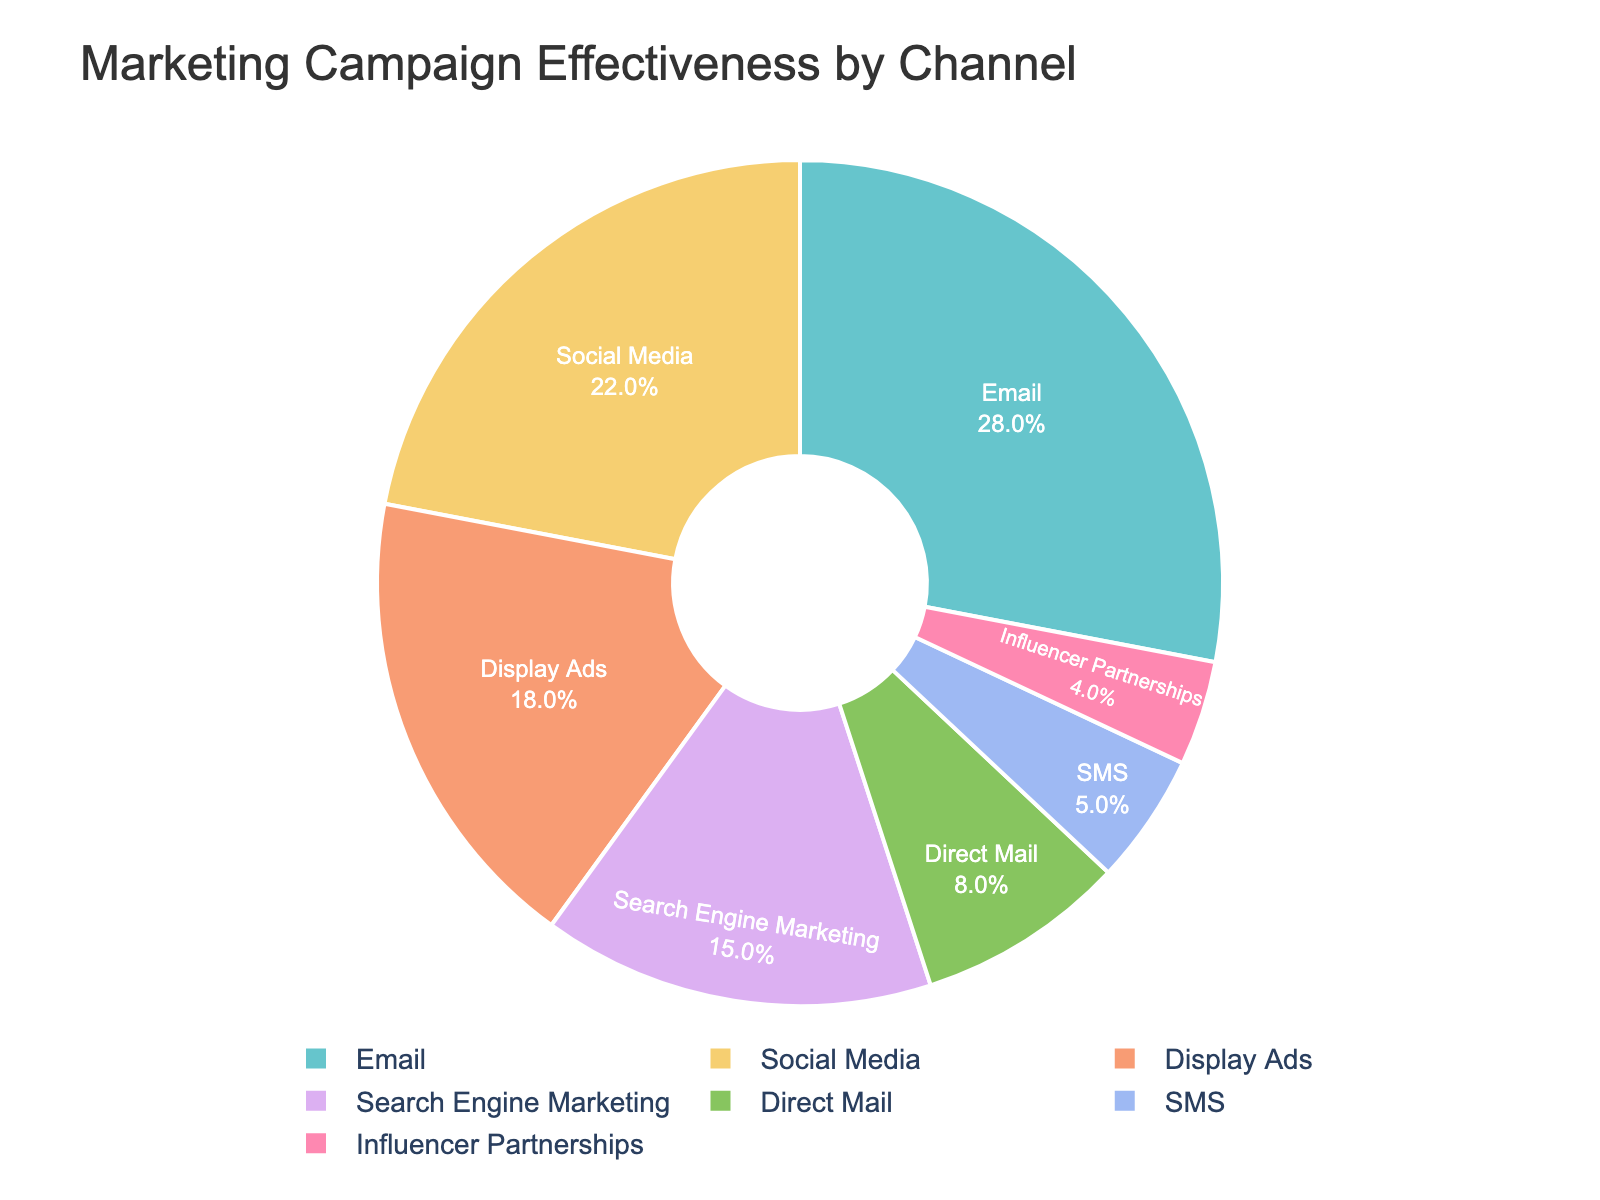What percentage of marketing campaign effectiveness does the Email channel contribute? To determine the percentage contribution of the Email channel, refer to the pie chart and look for the slice labeled "Email". The percentage will be displayed inside the slice.
Answer: 28% Which channel is more effective, Social Media or Display Ads? To compare the effectiveness of Social Media and Display Ads, look at their respective slices in the pie chart. Social Media has 22% while Display Ads has 18%.
Answer: Social Media What is the combined effectiveness percentage of the least effective channels (SMS and Influencer Partnerships)? The least effective channels are SMS and Influencer Partnerships. Their effectiveness percentages are 5% and 4%, respectively. Adding these together: 5% + 4% = 9%.
Answer: 9% Which channel has a higher effectiveness, Direct Mail or Search Engine Marketing? Compare the slices for Direct Mail (8%) and Search Engine Marketing (15%) in the pie chart. Search Engine Marketing has a higher effectiveness than Direct Mail.
Answer: Search Engine Marketing How much more effective is the Email channel compared to the Influencer Partnerships channel? To determine how much more effective the Email channel is compared to Influencer Partnerships, subtract the percentage of Influencer Partnerships from the Email channel: 28% - 4% = 24%.
Answer: 24% Which channel has the smallest contribution to marketing campaign effectiveness? Refer to the pie chart and look for the smallest slice. The smallest slice is labeled "Influencer Partnerships" with 4%.
Answer: Influencer Partnerships What percentage of marketing campaign effectiveness does the top three channels contribute combined? The top three channels by effectiveness are Email (28%), Social Media (22%), and Display Ads (18%). Adding these together: 28% + 22% + 18% = 68%.
Answer: 68% How do the effectiveness percentages of Display Ads and Search Engine Marketing compare visually? Visually, the slices for Display Ads and Search Engine Marketing can be compared by their sizes in the pie chart. Display Ads cover a larger area (18%) compared to Search Engine Marketing (15%).
Answer: Display Ads are larger Which channel has the third highest effectiveness percentage and what is that percentage? Identify the channels by descending order of percentages. Email is first (28%), Social Media is second (22%), and Display Ads is third with 18%.
Answer: Display Ads, 18% How much total effectiveness is contributed by the channels other than Email? Subtract the effectiveness percentage of Email from 100%. Total of other channels' effectiveness: 100% - 28% = 72%.
Answer: 72% 